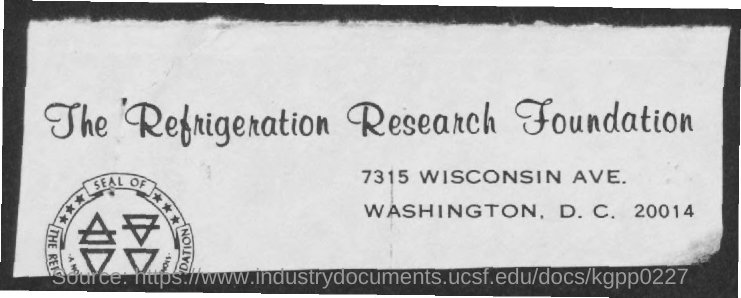List a handful of essential elements in this visual. The Refrigeration Research Foundation is the name of a foundation that is mentioned. 